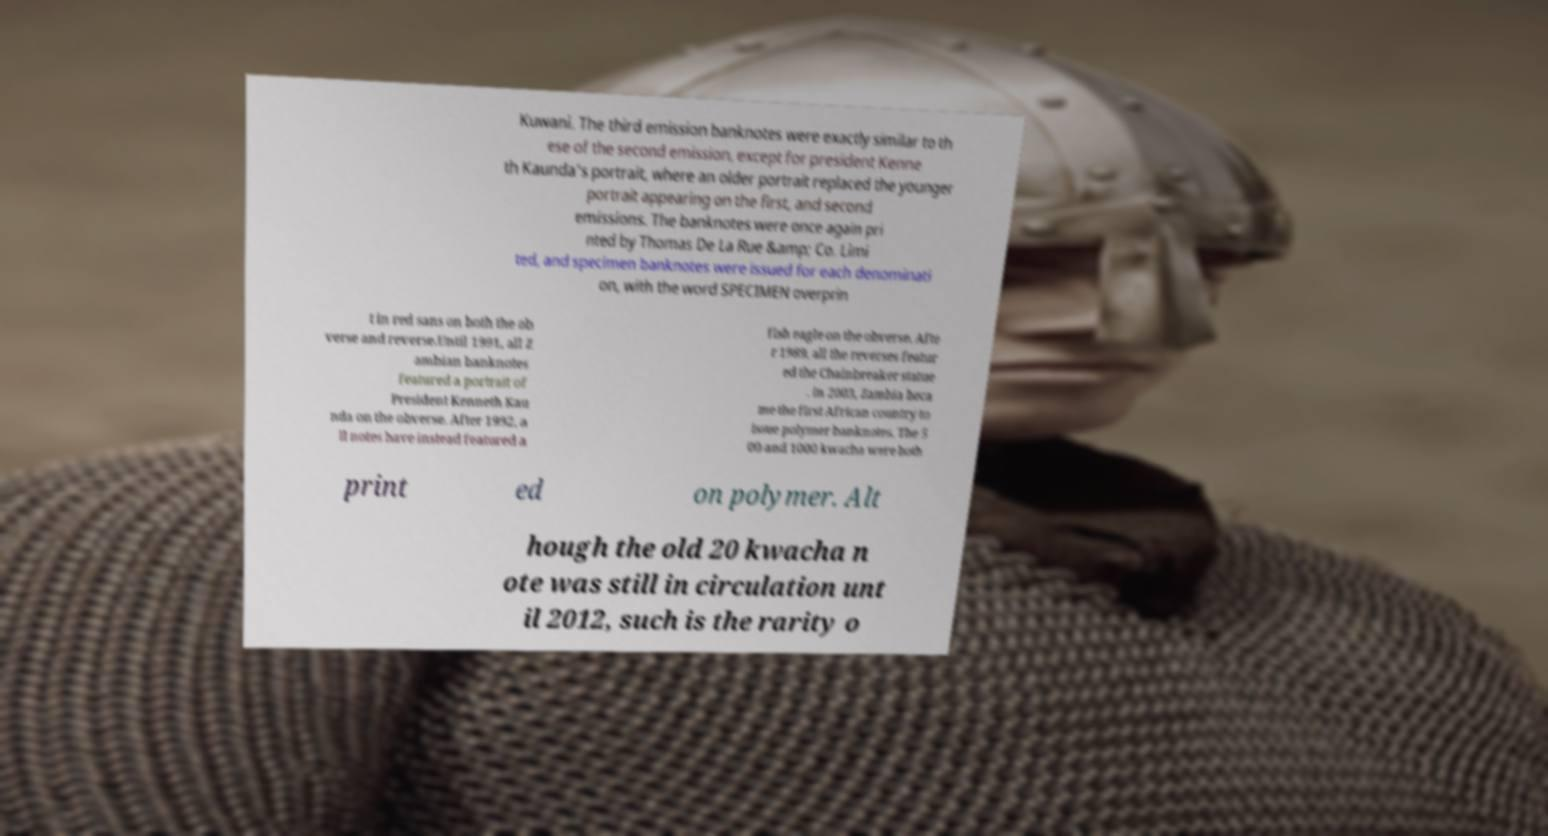Please read and relay the text visible in this image. What does it say? Kuwani. The third emission banknotes were exactly similar to th ese of the second emission, except for president Kenne th Kaunda's portrait, where an older portrait replaced the younger portrait appearing on the first, and second emissions. The banknotes were once again pri nted by Thomas De La Rue &amp; Co. Limi ted, and specimen banknotes were issued for each denominati on, with the word SPECIMEN overprin t in red sans on both the ob verse and reverse.Until 1991, all Z ambian banknotes featured a portrait of President Kenneth Kau nda on the obverse. After 1992, a ll notes have instead featured a fish eagle on the obverse. Afte r 1989, all the reverses featur ed the Chainbreaker statue . In 2003, Zambia beca me the first African country to issue polymer banknotes. The 5 00 and 1000 kwacha were both print ed on polymer. Alt hough the old 20 kwacha n ote was still in circulation unt il 2012, such is the rarity o 